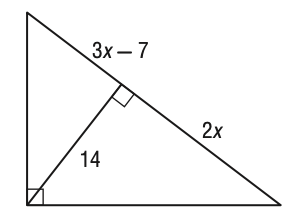Answer the mathemtical geometry problem and directly provide the correct option letter.
Question: What is the value of x in the figure below?
Choices: A: 5 B: 7 C: 8 D: 10 B 